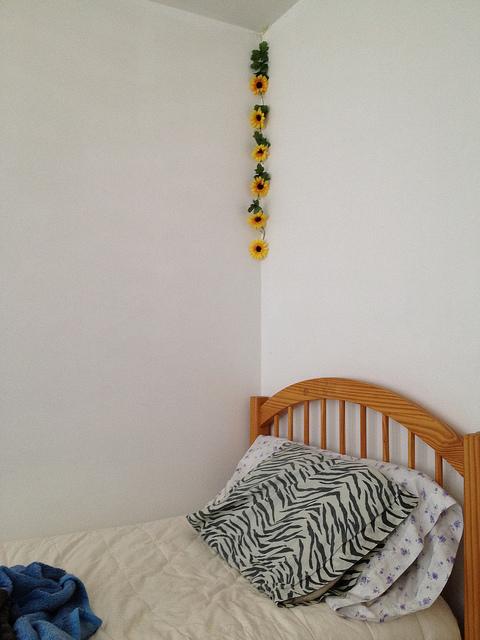Where is the zebra striped pillow?
Give a very brief answer. On bed. Is there flowers on the wall?
Quick response, please. Yes. Is this bed made?
Give a very brief answer. Yes. 